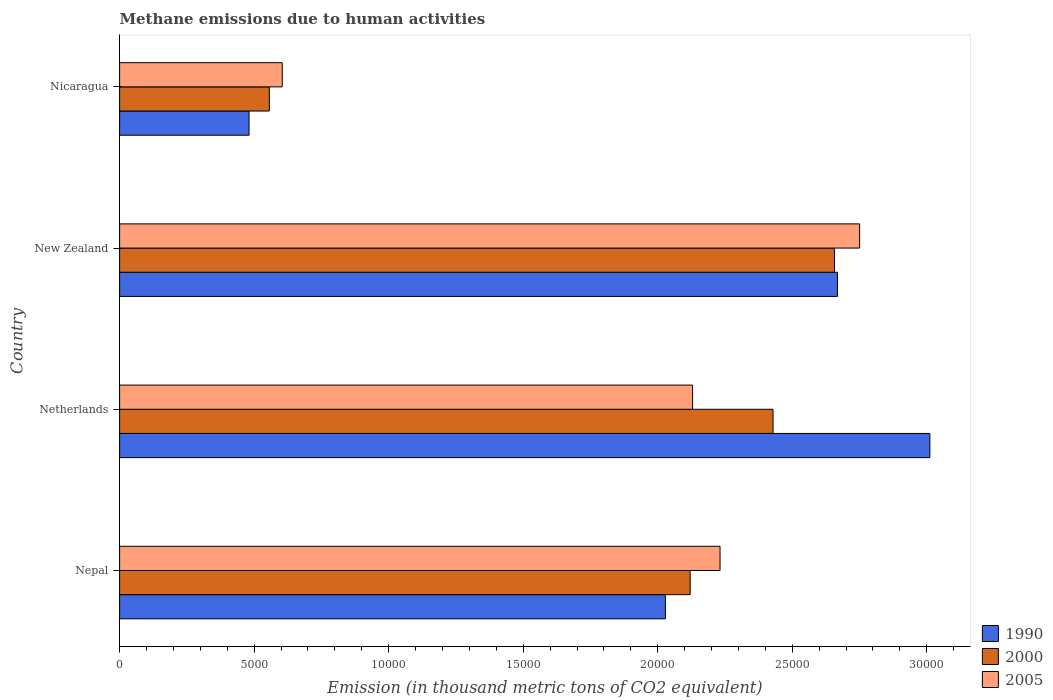How many groups of bars are there?
Ensure brevity in your answer.  4. Are the number of bars on each tick of the Y-axis equal?
Give a very brief answer. Yes. How many bars are there on the 3rd tick from the top?
Your answer should be compact. 3. What is the label of the 4th group of bars from the top?
Offer a very short reply. Nepal. In how many cases, is the number of bars for a given country not equal to the number of legend labels?
Offer a very short reply. 0. What is the amount of methane emitted in 1990 in Netherlands?
Your answer should be very brief. 3.01e+04. Across all countries, what is the maximum amount of methane emitted in 2000?
Keep it short and to the point. 2.66e+04. Across all countries, what is the minimum amount of methane emitted in 2005?
Offer a terse response. 6045. In which country was the amount of methane emitted in 2000 maximum?
Your response must be concise. New Zealand. In which country was the amount of methane emitted in 2000 minimum?
Offer a very short reply. Nicaragua. What is the total amount of methane emitted in 1990 in the graph?
Give a very brief answer. 8.19e+04. What is the difference between the amount of methane emitted in 2000 in Nepal and that in Netherlands?
Give a very brief answer. -3080.3. What is the difference between the amount of methane emitted in 2000 in New Zealand and the amount of methane emitted in 1990 in Nicaragua?
Ensure brevity in your answer.  2.18e+04. What is the average amount of methane emitted in 2005 per country?
Your answer should be compact. 1.93e+04. What is the difference between the amount of methane emitted in 2000 and amount of methane emitted in 1990 in Nicaragua?
Provide a succinct answer. 754.4. In how many countries, is the amount of methane emitted in 2005 greater than 4000 thousand metric tons?
Provide a short and direct response. 4. What is the ratio of the amount of methane emitted in 2000 in Nepal to that in New Zealand?
Keep it short and to the point. 0.8. What is the difference between the highest and the second highest amount of methane emitted in 2005?
Keep it short and to the point. 5187.6. What is the difference between the highest and the lowest amount of methane emitted in 2005?
Keep it short and to the point. 2.15e+04. Is the sum of the amount of methane emitted in 2005 in Nepal and Nicaragua greater than the maximum amount of methane emitted in 1990 across all countries?
Offer a very short reply. No. What does the 2nd bar from the top in Nepal represents?
Give a very brief answer. 2000. What does the 2nd bar from the bottom in Netherlands represents?
Offer a very short reply. 2000. How many bars are there?
Offer a very short reply. 12. How many countries are there in the graph?
Provide a short and direct response. 4. Does the graph contain any zero values?
Give a very brief answer. No. Does the graph contain grids?
Make the answer very short. No. Where does the legend appear in the graph?
Keep it short and to the point. Bottom right. How are the legend labels stacked?
Your response must be concise. Vertical. What is the title of the graph?
Offer a very short reply. Methane emissions due to human activities. What is the label or title of the X-axis?
Ensure brevity in your answer.  Emission (in thousand metric tons of CO2 equivalent). What is the label or title of the Y-axis?
Ensure brevity in your answer.  Country. What is the Emission (in thousand metric tons of CO2 equivalent) in 1990 in Nepal?
Keep it short and to the point. 2.03e+04. What is the Emission (in thousand metric tons of CO2 equivalent) in 2000 in Nepal?
Offer a very short reply. 2.12e+04. What is the Emission (in thousand metric tons of CO2 equivalent) of 2005 in Nepal?
Ensure brevity in your answer.  2.23e+04. What is the Emission (in thousand metric tons of CO2 equivalent) of 1990 in Netherlands?
Offer a very short reply. 3.01e+04. What is the Emission (in thousand metric tons of CO2 equivalent) in 2000 in Netherlands?
Your answer should be compact. 2.43e+04. What is the Emission (in thousand metric tons of CO2 equivalent) of 2005 in Netherlands?
Provide a succinct answer. 2.13e+04. What is the Emission (in thousand metric tons of CO2 equivalent) of 1990 in New Zealand?
Ensure brevity in your answer.  2.67e+04. What is the Emission (in thousand metric tons of CO2 equivalent) of 2000 in New Zealand?
Make the answer very short. 2.66e+04. What is the Emission (in thousand metric tons of CO2 equivalent) of 2005 in New Zealand?
Ensure brevity in your answer.  2.75e+04. What is the Emission (in thousand metric tons of CO2 equivalent) of 1990 in Nicaragua?
Give a very brief answer. 4811.3. What is the Emission (in thousand metric tons of CO2 equivalent) of 2000 in Nicaragua?
Keep it short and to the point. 5565.7. What is the Emission (in thousand metric tons of CO2 equivalent) in 2005 in Nicaragua?
Your answer should be very brief. 6045. Across all countries, what is the maximum Emission (in thousand metric tons of CO2 equivalent) of 1990?
Keep it short and to the point. 3.01e+04. Across all countries, what is the maximum Emission (in thousand metric tons of CO2 equivalent) of 2000?
Keep it short and to the point. 2.66e+04. Across all countries, what is the maximum Emission (in thousand metric tons of CO2 equivalent) of 2005?
Give a very brief answer. 2.75e+04. Across all countries, what is the minimum Emission (in thousand metric tons of CO2 equivalent) of 1990?
Your answer should be very brief. 4811.3. Across all countries, what is the minimum Emission (in thousand metric tons of CO2 equivalent) in 2000?
Provide a succinct answer. 5565.7. Across all countries, what is the minimum Emission (in thousand metric tons of CO2 equivalent) in 2005?
Your response must be concise. 6045. What is the total Emission (in thousand metric tons of CO2 equivalent) in 1990 in the graph?
Provide a short and direct response. 8.19e+04. What is the total Emission (in thousand metric tons of CO2 equivalent) of 2000 in the graph?
Offer a very short reply. 7.76e+04. What is the total Emission (in thousand metric tons of CO2 equivalent) of 2005 in the graph?
Make the answer very short. 7.72e+04. What is the difference between the Emission (in thousand metric tons of CO2 equivalent) of 1990 in Nepal and that in Netherlands?
Provide a succinct answer. -9828.9. What is the difference between the Emission (in thousand metric tons of CO2 equivalent) in 2000 in Nepal and that in Netherlands?
Provide a short and direct response. -3080.3. What is the difference between the Emission (in thousand metric tons of CO2 equivalent) in 2005 in Nepal and that in Netherlands?
Offer a very short reply. 1020.8. What is the difference between the Emission (in thousand metric tons of CO2 equivalent) of 1990 in Nepal and that in New Zealand?
Offer a terse response. -6394.7. What is the difference between the Emission (in thousand metric tons of CO2 equivalent) in 2000 in Nepal and that in New Zealand?
Keep it short and to the point. -5363.8. What is the difference between the Emission (in thousand metric tons of CO2 equivalent) of 2005 in Nepal and that in New Zealand?
Offer a very short reply. -5187.6. What is the difference between the Emission (in thousand metric tons of CO2 equivalent) of 1990 in Nepal and that in Nicaragua?
Your answer should be very brief. 1.55e+04. What is the difference between the Emission (in thousand metric tons of CO2 equivalent) in 2000 in Nepal and that in Nicaragua?
Your answer should be compact. 1.56e+04. What is the difference between the Emission (in thousand metric tons of CO2 equivalent) in 2005 in Nepal and that in Nicaragua?
Provide a short and direct response. 1.63e+04. What is the difference between the Emission (in thousand metric tons of CO2 equivalent) of 1990 in Netherlands and that in New Zealand?
Your answer should be very brief. 3434.2. What is the difference between the Emission (in thousand metric tons of CO2 equivalent) in 2000 in Netherlands and that in New Zealand?
Make the answer very short. -2283.5. What is the difference between the Emission (in thousand metric tons of CO2 equivalent) in 2005 in Netherlands and that in New Zealand?
Keep it short and to the point. -6208.4. What is the difference between the Emission (in thousand metric tons of CO2 equivalent) of 1990 in Netherlands and that in Nicaragua?
Offer a terse response. 2.53e+04. What is the difference between the Emission (in thousand metric tons of CO2 equivalent) in 2000 in Netherlands and that in Nicaragua?
Provide a succinct answer. 1.87e+04. What is the difference between the Emission (in thousand metric tons of CO2 equivalent) of 2005 in Netherlands and that in Nicaragua?
Offer a very short reply. 1.53e+04. What is the difference between the Emission (in thousand metric tons of CO2 equivalent) in 1990 in New Zealand and that in Nicaragua?
Provide a succinct answer. 2.19e+04. What is the difference between the Emission (in thousand metric tons of CO2 equivalent) of 2000 in New Zealand and that in Nicaragua?
Provide a succinct answer. 2.10e+04. What is the difference between the Emission (in thousand metric tons of CO2 equivalent) in 2005 in New Zealand and that in Nicaragua?
Give a very brief answer. 2.15e+04. What is the difference between the Emission (in thousand metric tons of CO2 equivalent) of 1990 in Nepal and the Emission (in thousand metric tons of CO2 equivalent) of 2000 in Netherlands?
Your answer should be very brief. -4000.6. What is the difference between the Emission (in thousand metric tons of CO2 equivalent) in 1990 in Nepal and the Emission (in thousand metric tons of CO2 equivalent) in 2005 in Netherlands?
Your answer should be compact. -1010.3. What is the difference between the Emission (in thousand metric tons of CO2 equivalent) in 2000 in Nepal and the Emission (in thousand metric tons of CO2 equivalent) in 2005 in Netherlands?
Provide a short and direct response. -90. What is the difference between the Emission (in thousand metric tons of CO2 equivalent) of 1990 in Nepal and the Emission (in thousand metric tons of CO2 equivalent) of 2000 in New Zealand?
Make the answer very short. -6284.1. What is the difference between the Emission (in thousand metric tons of CO2 equivalent) of 1990 in Nepal and the Emission (in thousand metric tons of CO2 equivalent) of 2005 in New Zealand?
Your answer should be compact. -7218.7. What is the difference between the Emission (in thousand metric tons of CO2 equivalent) of 2000 in Nepal and the Emission (in thousand metric tons of CO2 equivalent) of 2005 in New Zealand?
Your answer should be very brief. -6298.4. What is the difference between the Emission (in thousand metric tons of CO2 equivalent) of 1990 in Nepal and the Emission (in thousand metric tons of CO2 equivalent) of 2000 in Nicaragua?
Make the answer very short. 1.47e+04. What is the difference between the Emission (in thousand metric tons of CO2 equivalent) of 1990 in Nepal and the Emission (in thousand metric tons of CO2 equivalent) of 2005 in Nicaragua?
Ensure brevity in your answer.  1.42e+04. What is the difference between the Emission (in thousand metric tons of CO2 equivalent) in 2000 in Nepal and the Emission (in thousand metric tons of CO2 equivalent) in 2005 in Nicaragua?
Keep it short and to the point. 1.52e+04. What is the difference between the Emission (in thousand metric tons of CO2 equivalent) in 1990 in Netherlands and the Emission (in thousand metric tons of CO2 equivalent) in 2000 in New Zealand?
Ensure brevity in your answer.  3544.8. What is the difference between the Emission (in thousand metric tons of CO2 equivalent) of 1990 in Netherlands and the Emission (in thousand metric tons of CO2 equivalent) of 2005 in New Zealand?
Make the answer very short. 2610.2. What is the difference between the Emission (in thousand metric tons of CO2 equivalent) of 2000 in Netherlands and the Emission (in thousand metric tons of CO2 equivalent) of 2005 in New Zealand?
Offer a terse response. -3218.1. What is the difference between the Emission (in thousand metric tons of CO2 equivalent) of 1990 in Netherlands and the Emission (in thousand metric tons of CO2 equivalent) of 2000 in Nicaragua?
Your answer should be very brief. 2.45e+04. What is the difference between the Emission (in thousand metric tons of CO2 equivalent) of 1990 in Netherlands and the Emission (in thousand metric tons of CO2 equivalent) of 2005 in Nicaragua?
Keep it short and to the point. 2.41e+04. What is the difference between the Emission (in thousand metric tons of CO2 equivalent) in 2000 in Netherlands and the Emission (in thousand metric tons of CO2 equivalent) in 2005 in Nicaragua?
Offer a terse response. 1.82e+04. What is the difference between the Emission (in thousand metric tons of CO2 equivalent) of 1990 in New Zealand and the Emission (in thousand metric tons of CO2 equivalent) of 2000 in Nicaragua?
Your answer should be very brief. 2.11e+04. What is the difference between the Emission (in thousand metric tons of CO2 equivalent) of 1990 in New Zealand and the Emission (in thousand metric tons of CO2 equivalent) of 2005 in Nicaragua?
Your response must be concise. 2.06e+04. What is the difference between the Emission (in thousand metric tons of CO2 equivalent) in 2000 in New Zealand and the Emission (in thousand metric tons of CO2 equivalent) in 2005 in Nicaragua?
Offer a terse response. 2.05e+04. What is the average Emission (in thousand metric tons of CO2 equivalent) in 1990 per country?
Provide a short and direct response. 2.05e+04. What is the average Emission (in thousand metric tons of CO2 equivalent) in 2000 per country?
Your answer should be compact. 1.94e+04. What is the average Emission (in thousand metric tons of CO2 equivalent) in 2005 per country?
Ensure brevity in your answer.  1.93e+04. What is the difference between the Emission (in thousand metric tons of CO2 equivalent) in 1990 and Emission (in thousand metric tons of CO2 equivalent) in 2000 in Nepal?
Offer a very short reply. -920.3. What is the difference between the Emission (in thousand metric tons of CO2 equivalent) in 1990 and Emission (in thousand metric tons of CO2 equivalent) in 2005 in Nepal?
Give a very brief answer. -2031.1. What is the difference between the Emission (in thousand metric tons of CO2 equivalent) in 2000 and Emission (in thousand metric tons of CO2 equivalent) in 2005 in Nepal?
Provide a short and direct response. -1110.8. What is the difference between the Emission (in thousand metric tons of CO2 equivalent) in 1990 and Emission (in thousand metric tons of CO2 equivalent) in 2000 in Netherlands?
Provide a succinct answer. 5828.3. What is the difference between the Emission (in thousand metric tons of CO2 equivalent) in 1990 and Emission (in thousand metric tons of CO2 equivalent) in 2005 in Netherlands?
Your response must be concise. 8818.6. What is the difference between the Emission (in thousand metric tons of CO2 equivalent) in 2000 and Emission (in thousand metric tons of CO2 equivalent) in 2005 in Netherlands?
Ensure brevity in your answer.  2990.3. What is the difference between the Emission (in thousand metric tons of CO2 equivalent) of 1990 and Emission (in thousand metric tons of CO2 equivalent) of 2000 in New Zealand?
Make the answer very short. 110.6. What is the difference between the Emission (in thousand metric tons of CO2 equivalent) in 1990 and Emission (in thousand metric tons of CO2 equivalent) in 2005 in New Zealand?
Your answer should be compact. -824. What is the difference between the Emission (in thousand metric tons of CO2 equivalent) of 2000 and Emission (in thousand metric tons of CO2 equivalent) of 2005 in New Zealand?
Offer a terse response. -934.6. What is the difference between the Emission (in thousand metric tons of CO2 equivalent) in 1990 and Emission (in thousand metric tons of CO2 equivalent) in 2000 in Nicaragua?
Your response must be concise. -754.4. What is the difference between the Emission (in thousand metric tons of CO2 equivalent) of 1990 and Emission (in thousand metric tons of CO2 equivalent) of 2005 in Nicaragua?
Your answer should be compact. -1233.7. What is the difference between the Emission (in thousand metric tons of CO2 equivalent) in 2000 and Emission (in thousand metric tons of CO2 equivalent) in 2005 in Nicaragua?
Make the answer very short. -479.3. What is the ratio of the Emission (in thousand metric tons of CO2 equivalent) in 1990 in Nepal to that in Netherlands?
Offer a very short reply. 0.67. What is the ratio of the Emission (in thousand metric tons of CO2 equivalent) of 2000 in Nepal to that in Netherlands?
Your response must be concise. 0.87. What is the ratio of the Emission (in thousand metric tons of CO2 equivalent) of 2005 in Nepal to that in Netherlands?
Provide a short and direct response. 1.05. What is the ratio of the Emission (in thousand metric tons of CO2 equivalent) in 1990 in Nepal to that in New Zealand?
Provide a succinct answer. 0.76. What is the ratio of the Emission (in thousand metric tons of CO2 equivalent) of 2000 in Nepal to that in New Zealand?
Offer a terse response. 0.8. What is the ratio of the Emission (in thousand metric tons of CO2 equivalent) in 2005 in Nepal to that in New Zealand?
Your answer should be compact. 0.81. What is the ratio of the Emission (in thousand metric tons of CO2 equivalent) in 1990 in Nepal to that in Nicaragua?
Keep it short and to the point. 4.22. What is the ratio of the Emission (in thousand metric tons of CO2 equivalent) of 2000 in Nepal to that in Nicaragua?
Your answer should be compact. 3.81. What is the ratio of the Emission (in thousand metric tons of CO2 equivalent) of 2005 in Nepal to that in Nicaragua?
Your answer should be compact. 3.69. What is the ratio of the Emission (in thousand metric tons of CO2 equivalent) in 1990 in Netherlands to that in New Zealand?
Ensure brevity in your answer.  1.13. What is the ratio of the Emission (in thousand metric tons of CO2 equivalent) of 2000 in Netherlands to that in New Zealand?
Provide a short and direct response. 0.91. What is the ratio of the Emission (in thousand metric tons of CO2 equivalent) of 2005 in Netherlands to that in New Zealand?
Your response must be concise. 0.77. What is the ratio of the Emission (in thousand metric tons of CO2 equivalent) in 1990 in Netherlands to that in Nicaragua?
Provide a succinct answer. 6.26. What is the ratio of the Emission (in thousand metric tons of CO2 equivalent) in 2000 in Netherlands to that in Nicaragua?
Provide a short and direct response. 4.36. What is the ratio of the Emission (in thousand metric tons of CO2 equivalent) of 2005 in Netherlands to that in Nicaragua?
Offer a terse response. 3.52. What is the ratio of the Emission (in thousand metric tons of CO2 equivalent) in 1990 in New Zealand to that in Nicaragua?
Keep it short and to the point. 5.55. What is the ratio of the Emission (in thousand metric tons of CO2 equivalent) of 2000 in New Zealand to that in Nicaragua?
Your answer should be very brief. 4.77. What is the ratio of the Emission (in thousand metric tons of CO2 equivalent) of 2005 in New Zealand to that in Nicaragua?
Your answer should be very brief. 4.55. What is the difference between the highest and the second highest Emission (in thousand metric tons of CO2 equivalent) of 1990?
Your answer should be very brief. 3434.2. What is the difference between the highest and the second highest Emission (in thousand metric tons of CO2 equivalent) in 2000?
Your answer should be compact. 2283.5. What is the difference between the highest and the second highest Emission (in thousand metric tons of CO2 equivalent) of 2005?
Provide a short and direct response. 5187.6. What is the difference between the highest and the lowest Emission (in thousand metric tons of CO2 equivalent) in 1990?
Give a very brief answer. 2.53e+04. What is the difference between the highest and the lowest Emission (in thousand metric tons of CO2 equivalent) of 2000?
Provide a short and direct response. 2.10e+04. What is the difference between the highest and the lowest Emission (in thousand metric tons of CO2 equivalent) in 2005?
Your answer should be very brief. 2.15e+04. 